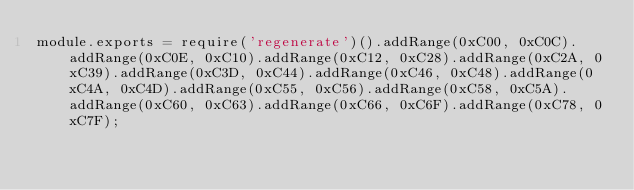Convert code to text. <code><loc_0><loc_0><loc_500><loc_500><_JavaScript_>module.exports = require('regenerate')().addRange(0xC00, 0xC0C).addRange(0xC0E, 0xC10).addRange(0xC12, 0xC28).addRange(0xC2A, 0xC39).addRange(0xC3D, 0xC44).addRange(0xC46, 0xC48).addRange(0xC4A, 0xC4D).addRange(0xC55, 0xC56).addRange(0xC58, 0xC5A).addRange(0xC60, 0xC63).addRange(0xC66, 0xC6F).addRange(0xC78, 0xC7F);
</code> 